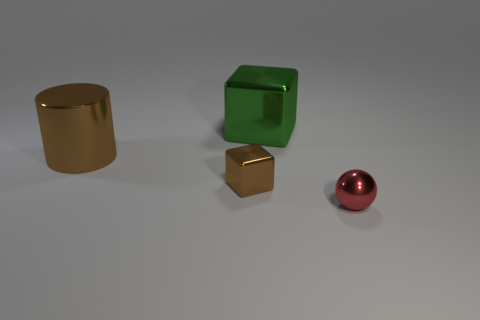Add 2 large green things. How many objects exist? 6 Subtract all cylinders. How many objects are left? 3 Add 3 large objects. How many large objects are left? 5 Add 1 brown shiny objects. How many brown shiny objects exist? 3 Subtract 0 blue cubes. How many objects are left? 4 Subtract all brown blocks. Subtract all blocks. How many objects are left? 1 